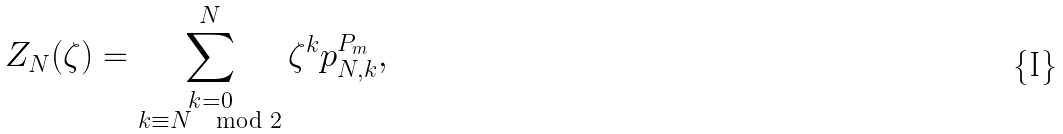Convert formula to latex. <formula><loc_0><loc_0><loc_500><loc_500>Z _ { N } ( \zeta ) = \sum _ { \substack { k = 0 \\ k \equiv N \mod 2 } } ^ { N } \zeta ^ { k } p _ { N , k } ^ { P _ { m } } ,</formula> 